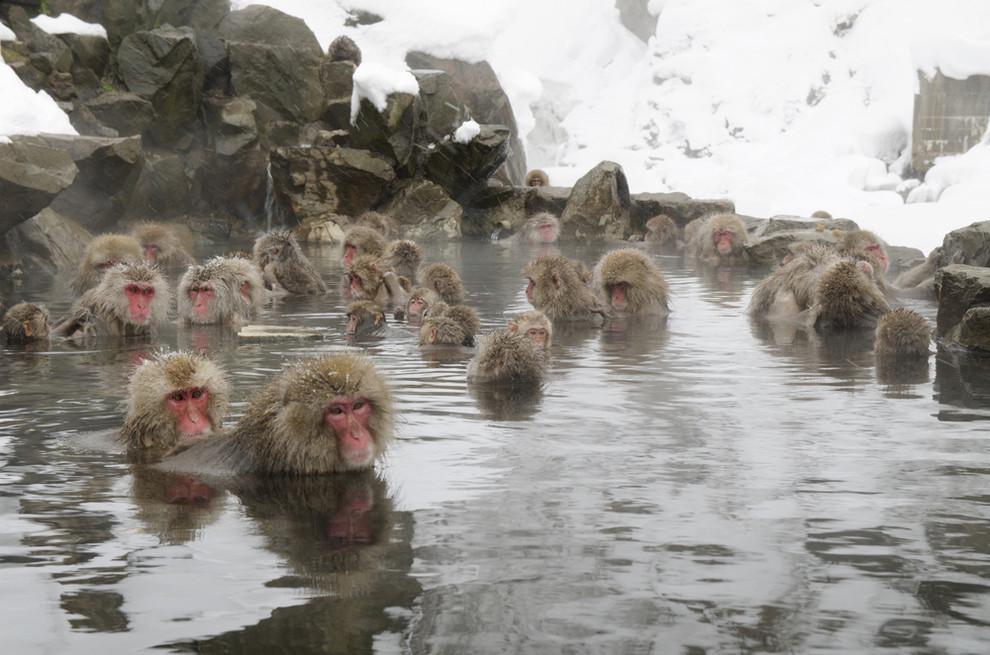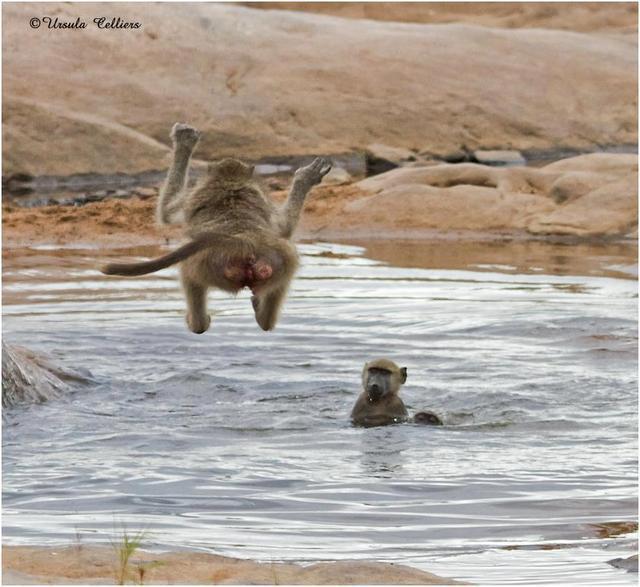The first image is the image on the left, the second image is the image on the right. Examine the images to the left and right. Is the description "An animal in the image on the right is sitting on a concrete railing." accurate? Answer yes or no. No. The first image is the image on the left, the second image is the image on the right. Evaluate the accuracy of this statement regarding the images: "An image includes a baboon sitting on a manmade ledge of a pool.". Is it true? Answer yes or no. No. 